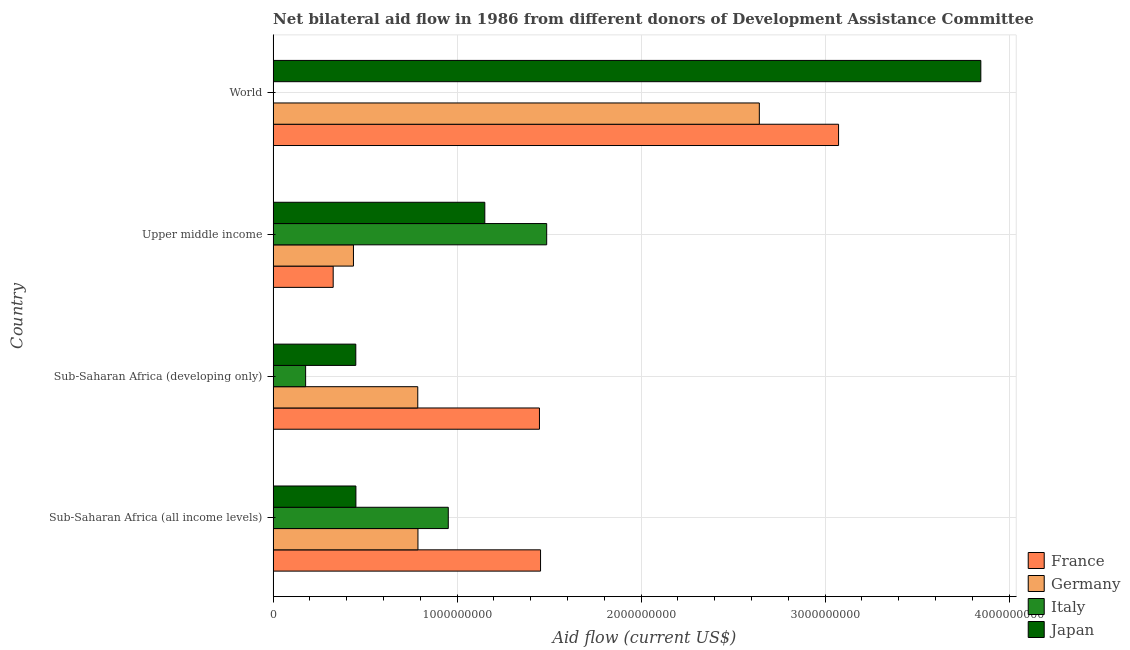How many different coloured bars are there?
Your answer should be compact. 4. Are the number of bars per tick equal to the number of legend labels?
Your response must be concise. Yes. How many bars are there on the 1st tick from the top?
Make the answer very short. 4. How many bars are there on the 3rd tick from the bottom?
Offer a very short reply. 4. What is the label of the 1st group of bars from the top?
Ensure brevity in your answer.  World. What is the amount of aid given by germany in Upper middle income?
Provide a succinct answer. 4.37e+08. Across all countries, what is the maximum amount of aid given by france?
Your answer should be compact. 3.07e+09. Across all countries, what is the minimum amount of aid given by germany?
Your response must be concise. 4.37e+08. In which country was the amount of aid given by italy maximum?
Your answer should be very brief. Upper middle income. In which country was the amount of aid given by italy minimum?
Your response must be concise. World. What is the total amount of aid given by japan in the graph?
Give a very brief answer. 5.90e+09. What is the difference between the amount of aid given by italy in Sub-Saharan Africa (developing only) and that in World?
Make the answer very short. 1.76e+08. What is the difference between the amount of aid given by italy in Sub-Saharan Africa (all income levels) and the amount of aid given by japan in Upper middle income?
Give a very brief answer. -1.99e+08. What is the average amount of aid given by italy per country?
Give a very brief answer. 6.54e+08. What is the difference between the amount of aid given by germany and amount of aid given by japan in Sub-Saharan Africa (developing only)?
Ensure brevity in your answer.  3.37e+08. In how many countries, is the amount of aid given by italy greater than 3600000000 US$?
Provide a short and direct response. 0. What is the ratio of the amount of aid given by japan in Upper middle income to that in World?
Offer a very short reply. 0.3. Is the difference between the amount of aid given by france in Upper middle income and World greater than the difference between the amount of aid given by italy in Upper middle income and World?
Keep it short and to the point. No. What is the difference between the highest and the second highest amount of aid given by italy?
Your answer should be compact. 5.35e+08. What is the difference between the highest and the lowest amount of aid given by japan?
Provide a short and direct response. 3.40e+09. In how many countries, is the amount of aid given by france greater than the average amount of aid given by france taken over all countries?
Your answer should be very brief. 1. Is it the case that in every country, the sum of the amount of aid given by germany and amount of aid given by italy is greater than the sum of amount of aid given by france and amount of aid given by japan?
Provide a short and direct response. No. What does the 2nd bar from the top in Sub-Saharan Africa (developing only) represents?
Give a very brief answer. Italy. What does the 4th bar from the bottom in Sub-Saharan Africa (developing only) represents?
Your answer should be very brief. Japan. How many bars are there?
Provide a succinct answer. 16. How many countries are there in the graph?
Make the answer very short. 4. Are the values on the major ticks of X-axis written in scientific E-notation?
Give a very brief answer. No. Does the graph contain any zero values?
Your answer should be compact. No. Does the graph contain grids?
Make the answer very short. Yes. Where does the legend appear in the graph?
Your answer should be compact. Bottom right. How many legend labels are there?
Make the answer very short. 4. How are the legend labels stacked?
Give a very brief answer. Vertical. What is the title of the graph?
Keep it short and to the point. Net bilateral aid flow in 1986 from different donors of Development Assistance Committee. Does "Taxes on revenue" appear as one of the legend labels in the graph?
Keep it short and to the point. No. What is the label or title of the X-axis?
Provide a short and direct response. Aid flow (current US$). What is the label or title of the Y-axis?
Give a very brief answer. Country. What is the Aid flow (current US$) of France in Sub-Saharan Africa (all income levels)?
Give a very brief answer. 1.45e+09. What is the Aid flow (current US$) of Germany in Sub-Saharan Africa (all income levels)?
Offer a very short reply. 7.87e+08. What is the Aid flow (current US$) in Italy in Sub-Saharan Africa (all income levels)?
Provide a succinct answer. 9.52e+08. What is the Aid flow (current US$) in Japan in Sub-Saharan Africa (all income levels)?
Give a very brief answer. 4.50e+08. What is the Aid flow (current US$) in France in Sub-Saharan Africa (developing only)?
Provide a short and direct response. 1.45e+09. What is the Aid flow (current US$) in Germany in Sub-Saharan Africa (developing only)?
Keep it short and to the point. 7.86e+08. What is the Aid flow (current US$) of Italy in Sub-Saharan Africa (developing only)?
Offer a very short reply. 1.77e+08. What is the Aid flow (current US$) of Japan in Sub-Saharan Africa (developing only)?
Provide a succinct answer. 4.49e+08. What is the Aid flow (current US$) of France in Upper middle income?
Offer a terse response. 3.26e+08. What is the Aid flow (current US$) of Germany in Upper middle income?
Your answer should be very brief. 4.37e+08. What is the Aid flow (current US$) of Italy in Upper middle income?
Give a very brief answer. 1.49e+09. What is the Aid flow (current US$) of Japan in Upper middle income?
Make the answer very short. 1.15e+09. What is the Aid flow (current US$) of France in World?
Give a very brief answer. 3.07e+09. What is the Aid flow (current US$) in Germany in World?
Provide a succinct answer. 2.64e+09. What is the Aid flow (current US$) in Italy in World?
Make the answer very short. 6.90e+05. What is the Aid flow (current US$) of Japan in World?
Offer a very short reply. 3.85e+09. Across all countries, what is the maximum Aid flow (current US$) of France?
Provide a succinct answer. 3.07e+09. Across all countries, what is the maximum Aid flow (current US$) in Germany?
Your answer should be very brief. 2.64e+09. Across all countries, what is the maximum Aid flow (current US$) of Italy?
Keep it short and to the point. 1.49e+09. Across all countries, what is the maximum Aid flow (current US$) of Japan?
Ensure brevity in your answer.  3.85e+09. Across all countries, what is the minimum Aid flow (current US$) in France?
Offer a very short reply. 3.26e+08. Across all countries, what is the minimum Aid flow (current US$) in Germany?
Provide a succinct answer. 4.37e+08. Across all countries, what is the minimum Aid flow (current US$) in Italy?
Ensure brevity in your answer.  6.90e+05. Across all countries, what is the minimum Aid flow (current US$) in Japan?
Offer a terse response. 4.49e+08. What is the total Aid flow (current US$) in France in the graph?
Your answer should be compact. 6.30e+09. What is the total Aid flow (current US$) of Germany in the graph?
Ensure brevity in your answer.  4.65e+09. What is the total Aid flow (current US$) in Italy in the graph?
Your answer should be compact. 2.62e+09. What is the total Aid flow (current US$) of Japan in the graph?
Your answer should be compact. 5.90e+09. What is the difference between the Aid flow (current US$) of France in Sub-Saharan Africa (all income levels) and that in Sub-Saharan Africa (developing only)?
Keep it short and to the point. 5.92e+06. What is the difference between the Aid flow (current US$) of Germany in Sub-Saharan Africa (all income levels) and that in Sub-Saharan Africa (developing only)?
Your answer should be compact. 1.05e+06. What is the difference between the Aid flow (current US$) of Italy in Sub-Saharan Africa (all income levels) and that in Sub-Saharan Africa (developing only)?
Your answer should be very brief. 7.75e+08. What is the difference between the Aid flow (current US$) in Japan in Sub-Saharan Africa (all income levels) and that in Sub-Saharan Africa (developing only)?
Keep it short and to the point. 5.90e+05. What is the difference between the Aid flow (current US$) of France in Sub-Saharan Africa (all income levels) and that in Upper middle income?
Give a very brief answer. 1.13e+09. What is the difference between the Aid flow (current US$) of Germany in Sub-Saharan Africa (all income levels) and that in Upper middle income?
Ensure brevity in your answer.  3.51e+08. What is the difference between the Aid flow (current US$) in Italy in Sub-Saharan Africa (all income levels) and that in Upper middle income?
Make the answer very short. -5.35e+08. What is the difference between the Aid flow (current US$) in Japan in Sub-Saharan Africa (all income levels) and that in Upper middle income?
Provide a short and direct response. -7.01e+08. What is the difference between the Aid flow (current US$) of France in Sub-Saharan Africa (all income levels) and that in World?
Provide a succinct answer. -1.62e+09. What is the difference between the Aid flow (current US$) of Germany in Sub-Saharan Africa (all income levels) and that in World?
Provide a short and direct response. -1.86e+09. What is the difference between the Aid flow (current US$) of Italy in Sub-Saharan Africa (all income levels) and that in World?
Give a very brief answer. 9.51e+08. What is the difference between the Aid flow (current US$) of Japan in Sub-Saharan Africa (all income levels) and that in World?
Your answer should be compact. -3.40e+09. What is the difference between the Aid flow (current US$) of France in Sub-Saharan Africa (developing only) and that in Upper middle income?
Your response must be concise. 1.12e+09. What is the difference between the Aid flow (current US$) of Germany in Sub-Saharan Africa (developing only) and that in Upper middle income?
Provide a succinct answer. 3.50e+08. What is the difference between the Aid flow (current US$) of Italy in Sub-Saharan Africa (developing only) and that in Upper middle income?
Give a very brief answer. -1.31e+09. What is the difference between the Aid flow (current US$) in Japan in Sub-Saharan Africa (developing only) and that in Upper middle income?
Provide a short and direct response. -7.01e+08. What is the difference between the Aid flow (current US$) of France in Sub-Saharan Africa (developing only) and that in World?
Make the answer very short. -1.63e+09. What is the difference between the Aid flow (current US$) in Germany in Sub-Saharan Africa (developing only) and that in World?
Give a very brief answer. -1.86e+09. What is the difference between the Aid flow (current US$) of Italy in Sub-Saharan Africa (developing only) and that in World?
Provide a short and direct response. 1.76e+08. What is the difference between the Aid flow (current US$) of Japan in Sub-Saharan Africa (developing only) and that in World?
Provide a short and direct response. -3.40e+09. What is the difference between the Aid flow (current US$) in France in Upper middle income and that in World?
Make the answer very short. -2.75e+09. What is the difference between the Aid flow (current US$) in Germany in Upper middle income and that in World?
Make the answer very short. -2.21e+09. What is the difference between the Aid flow (current US$) in Italy in Upper middle income and that in World?
Provide a succinct answer. 1.49e+09. What is the difference between the Aid flow (current US$) of Japan in Upper middle income and that in World?
Make the answer very short. -2.70e+09. What is the difference between the Aid flow (current US$) of France in Sub-Saharan Africa (all income levels) and the Aid flow (current US$) of Germany in Sub-Saharan Africa (developing only)?
Make the answer very short. 6.67e+08. What is the difference between the Aid flow (current US$) in France in Sub-Saharan Africa (all income levels) and the Aid flow (current US$) in Italy in Sub-Saharan Africa (developing only)?
Provide a short and direct response. 1.28e+09. What is the difference between the Aid flow (current US$) of France in Sub-Saharan Africa (all income levels) and the Aid flow (current US$) of Japan in Sub-Saharan Africa (developing only)?
Provide a short and direct response. 1.00e+09. What is the difference between the Aid flow (current US$) of Germany in Sub-Saharan Africa (all income levels) and the Aid flow (current US$) of Italy in Sub-Saharan Africa (developing only)?
Your answer should be very brief. 6.11e+08. What is the difference between the Aid flow (current US$) in Germany in Sub-Saharan Africa (all income levels) and the Aid flow (current US$) in Japan in Sub-Saharan Africa (developing only)?
Provide a short and direct response. 3.38e+08. What is the difference between the Aid flow (current US$) in Italy in Sub-Saharan Africa (all income levels) and the Aid flow (current US$) in Japan in Sub-Saharan Africa (developing only)?
Offer a terse response. 5.03e+08. What is the difference between the Aid flow (current US$) of France in Sub-Saharan Africa (all income levels) and the Aid flow (current US$) of Germany in Upper middle income?
Your answer should be very brief. 1.02e+09. What is the difference between the Aid flow (current US$) in France in Sub-Saharan Africa (all income levels) and the Aid flow (current US$) in Italy in Upper middle income?
Your answer should be compact. -3.34e+07. What is the difference between the Aid flow (current US$) of France in Sub-Saharan Africa (all income levels) and the Aid flow (current US$) of Japan in Upper middle income?
Give a very brief answer. 3.03e+08. What is the difference between the Aid flow (current US$) in Germany in Sub-Saharan Africa (all income levels) and the Aid flow (current US$) in Italy in Upper middle income?
Offer a very short reply. -7.00e+08. What is the difference between the Aid flow (current US$) in Germany in Sub-Saharan Africa (all income levels) and the Aid flow (current US$) in Japan in Upper middle income?
Give a very brief answer. -3.63e+08. What is the difference between the Aid flow (current US$) of Italy in Sub-Saharan Africa (all income levels) and the Aid flow (current US$) of Japan in Upper middle income?
Provide a succinct answer. -1.99e+08. What is the difference between the Aid flow (current US$) in France in Sub-Saharan Africa (all income levels) and the Aid flow (current US$) in Germany in World?
Offer a terse response. -1.19e+09. What is the difference between the Aid flow (current US$) in France in Sub-Saharan Africa (all income levels) and the Aid flow (current US$) in Italy in World?
Give a very brief answer. 1.45e+09. What is the difference between the Aid flow (current US$) of France in Sub-Saharan Africa (all income levels) and the Aid flow (current US$) of Japan in World?
Ensure brevity in your answer.  -2.39e+09. What is the difference between the Aid flow (current US$) of Germany in Sub-Saharan Africa (all income levels) and the Aid flow (current US$) of Italy in World?
Offer a very short reply. 7.86e+08. What is the difference between the Aid flow (current US$) in Germany in Sub-Saharan Africa (all income levels) and the Aid flow (current US$) in Japan in World?
Make the answer very short. -3.06e+09. What is the difference between the Aid flow (current US$) of Italy in Sub-Saharan Africa (all income levels) and the Aid flow (current US$) of Japan in World?
Keep it short and to the point. -2.89e+09. What is the difference between the Aid flow (current US$) in France in Sub-Saharan Africa (developing only) and the Aid flow (current US$) in Germany in Upper middle income?
Provide a short and direct response. 1.01e+09. What is the difference between the Aid flow (current US$) in France in Sub-Saharan Africa (developing only) and the Aid flow (current US$) in Italy in Upper middle income?
Ensure brevity in your answer.  -3.93e+07. What is the difference between the Aid flow (current US$) in France in Sub-Saharan Africa (developing only) and the Aid flow (current US$) in Japan in Upper middle income?
Offer a very short reply. 2.97e+08. What is the difference between the Aid flow (current US$) of Germany in Sub-Saharan Africa (developing only) and the Aid flow (current US$) of Italy in Upper middle income?
Provide a short and direct response. -7.01e+08. What is the difference between the Aid flow (current US$) of Germany in Sub-Saharan Africa (developing only) and the Aid flow (current US$) of Japan in Upper middle income?
Give a very brief answer. -3.64e+08. What is the difference between the Aid flow (current US$) in Italy in Sub-Saharan Africa (developing only) and the Aid flow (current US$) in Japan in Upper middle income?
Offer a terse response. -9.74e+08. What is the difference between the Aid flow (current US$) of France in Sub-Saharan Africa (developing only) and the Aid flow (current US$) of Germany in World?
Offer a very short reply. -1.19e+09. What is the difference between the Aid flow (current US$) in France in Sub-Saharan Africa (developing only) and the Aid flow (current US$) in Italy in World?
Your answer should be very brief. 1.45e+09. What is the difference between the Aid flow (current US$) of France in Sub-Saharan Africa (developing only) and the Aid flow (current US$) of Japan in World?
Provide a succinct answer. -2.40e+09. What is the difference between the Aid flow (current US$) in Germany in Sub-Saharan Africa (developing only) and the Aid flow (current US$) in Italy in World?
Your answer should be very brief. 7.85e+08. What is the difference between the Aid flow (current US$) in Germany in Sub-Saharan Africa (developing only) and the Aid flow (current US$) in Japan in World?
Offer a terse response. -3.06e+09. What is the difference between the Aid flow (current US$) in Italy in Sub-Saharan Africa (developing only) and the Aid flow (current US$) in Japan in World?
Offer a terse response. -3.67e+09. What is the difference between the Aid flow (current US$) of France in Upper middle income and the Aid flow (current US$) of Germany in World?
Provide a short and direct response. -2.32e+09. What is the difference between the Aid flow (current US$) in France in Upper middle income and the Aid flow (current US$) in Italy in World?
Give a very brief answer. 3.26e+08. What is the difference between the Aid flow (current US$) in France in Upper middle income and the Aid flow (current US$) in Japan in World?
Ensure brevity in your answer.  -3.52e+09. What is the difference between the Aid flow (current US$) in Germany in Upper middle income and the Aid flow (current US$) in Italy in World?
Give a very brief answer. 4.36e+08. What is the difference between the Aid flow (current US$) of Germany in Upper middle income and the Aid flow (current US$) of Japan in World?
Offer a terse response. -3.41e+09. What is the difference between the Aid flow (current US$) of Italy in Upper middle income and the Aid flow (current US$) of Japan in World?
Keep it short and to the point. -2.36e+09. What is the average Aid flow (current US$) of France per country?
Keep it short and to the point. 1.58e+09. What is the average Aid flow (current US$) of Germany per country?
Make the answer very short. 1.16e+09. What is the average Aid flow (current US$) in Italy per country?
Keep it short and to the point. 6.54e+08. What is the average Aid flow (current US$) of Japan per country?
Make the answer very short. 1.47e+09. What is the difference between the Aid flow (current US$) in France and Aid flow (current US$) in Germany in Sub-Saharan Africa (all income levels)?
Provide a short and direct response. 6.66e+08. What is the difference between the Aid flow (current US$) in France and Aid flow (current US$) in Italy in Sub-Saharan Africa (all income levels)?
Make the answer very short. 5.01e+08. What is the difference between the Aid flow (current US$) of France and Aid flow (current US$) of Japan in Sub-Saharan Africa (all income levels)?
Make the answer very short. 1.00e+09. What is the difference between the Aid flow (current US$) of Germany and Aid flow (current US$) of Italy in Sub-Saharan Africa (all income levels)?
Ensure brevity in your answer.  -1.65e+08. What is the difference between the Aid flow (current US$) of Germany and Aid flow (current US$) of Japan in Sub-Saharan Africa (all income levels)?
Provide a succinct answer. 3.37e+08. What is the difference between the Aid flow (current US$) of Italy and Aid flow (current US$) of Japan in Sub-Saharan Africa (all income levels)?
Make the answer very short. 5.02e+08. What is the difference between the Aid flow (current US$) of France and Aid flow (current US$) of Germany in Sub-Saharan Africa (developing only)?
Offer a terse response. 6.61e+08. What is the difference between the Aid flow (current US$) in France and Aid flow (current US$) in Italy in Sub-Saharan Africa (developing only)?
Your response must be concise. 1.27e+09. What is the difference between the Aid flow (current US$) in France and Aid flow (current US$) in Japan in Sub-Saharan Africa (developing only)?
Keep it short and to the point. 9.98e+08. What is the difference between the Aid flow (current US$) in Germany and Aid flow (current US$) in Italy in Sub-Saharan Africa (developing only)?
Your answer should be very brief. 6.10e+08. What is the difference between the Aid flow (current US$) in Germany and Aid flow (current US$) in Japan in Sub-Saharan Africa (developing only)?
Your answer should be very brief. 3.37e+08. What is the difference between the Aid flow (current US$) of Italy and Aid flow (current US$) of Japan in Sub-Saharan Africa (developing only)?
Provide a short and direct response. -2.73e+08. What is the difference between the Aid flow (current US$) of France and Aid flow (current US$) of Germany in Upper middle income?
Offer a terse response. -1.10e+08. What is the difference between the Aid flow (current US$) of France and Aid flow (current US$) of Italy in Upper middle income?
Your answer should be very brief. -1.16e+09. What is the difference between the Aid flow (current US$) in France and Aid flow (current US$) in Japan in Upper middle income?
Make the answer very short. -8.24e+08. What is the difference between the Aid flow (current US$) in Germany and Aid flow (current US$) in Italy in Upper middle income?
Offer a very short reply. -1.05e+09. What is the difference between the Aid flow (current US$) of Germany and Aid flow (current US$) of Japan in Upper middle income?
Offer a terse response. -7.14e+08. What is the difference between the Aid flow (current US$) of Italy and Aid flow (current US$) of Japan in Upper middle income?
Offer a very short reply. 3.36e+08. What is the difference between the Aid flow (current US$) of France and Aid flow (current US$) of Germany in World?
Provide a short and direct response. 4.31e+08. What is the difference between the Aid flow (current US$) in France and Aid flow (current US$) in Italy in World?
Offer a very short reply. 3.07e+09. What is the difference between the Aid flow (current US$) of France and Aid flow (current US$) of Japan in World?
Your answer should be compact. -7.73e+08. What is the difference between the Aid flow (current US$) of Germany and Aid flow (current US$) of Italy in World?
Make the answer very short. 2.64e+09. What is the difference between the Aid flow (current US$) in Germany and Aid flow (current US$) in Japan in World?
Your response must be concise. -1.20e+09. What is the difference between the Aid flow (current US$) of Italy and Aid flow (current US$) of Japan in World?
Your response must be concise. -3.85e+09. What is the ratio of the Aid flow (current US$) of Germany in Sub-Saharan Africa (all income levels) to that in Sub-Saharan Africa (developing only)?
Make the answer very short. 1. What is the ratio of the Aid flow (current US$) in Italy in Sub-Saharan Africa (all income levels) to that in Sub-Saharan Africa (developing only)?
Give a very brief answer. 5.39. What is the ratio of the Aid flow (current US$) of Japan in Sub-Saharan Africa (all income levels) to that in Sub-Saharan Africa (developing only)?
Your answer should be compact. 1. What is the ratio of the Aid flow (current US$) in France in Sub-Saharan Africa (all income levels) to that in Upper middle income?
Offer a terse response. 4.45. What is the ratio of the Aid flow (current US$) in Germany in Sub-Saharan Africa (all income levels) to that in Upper middle income?
Provide a succinct answer. 1.8. What is the ratio of the Aid flow (current US$) in Italy in Sub-Saharan Africa (all income levels) to that in Upper middle income?
Provide a succinct answer. 0.64. What is the ratio of the Aid flow (current US$) in Japan in Sub-Saharan Africa (all income levels) to that in Upper middle income?
Offer a terse response. 0.39. What is the ratio of the Aid flow (current US$) in France in Sub-Saharan Africa (all income levels) to that in World?
Offer a terse response. 0.47. What is the ratio of the Aid flow (current US$) of Germany in Sub-Saharan Africa (all income levels) to that in World?
Provide a short and direct response. 0.3. What is the ratio of the Aid flow (current US$) in Italy in Sub-Saharan Africa (all income levels) to that in World?
Your response must be concise. 1379.68. What is the ratio of the Aid flow (current US$) of Japan in Sub-Saharan Africa (all income levels) to that in World?
Offer a very short reply. 0.12. What is the ratio of the Aid flow (current US$) of France in Sub-Saharan Africa (developing only) to that in Upper middle income?
Your response must be concise. 4.43. What is the ratio of the Aid flow (current US$) of Germany in Sub-Saharan Africa (developing only) to that in Upper middle income?
Offer a very short reply. 1.8. What is the ratio of the Aid flow (current US$) of Italy in Sub-Saharan Africa (developing only) to that in Upper middle income?
Keep it short and to the point. 0.12. What is the ratio of the Aid flow (current US$) in Japan in Sub-Saharan Africa (developing only) to that in Upper middle income?
Make the answer very short. 0.39. What is the ratio of the Aid flow (current US$) of France in Sub-Saharan Africa (developing only) to that in World?
Offer a terse response. 0.47. What is the ratio of the Aid flow (current US$) of Germany in Sub-Saharan Africa (developing only) to that in World?
Give a very brief answer. 0.3. What is the ratio of the Aid flow (current US$) of Italy in Sub-Saharan Africa (developing only) to that in World?
Offer a very short reply. 255.99. What is the ratio of the Aid flow (current US$) of Japan in Sub-Saharan Africa (developing only) to that in World?
Make the answer very short. 0.12. What is the ratio of the Aid flow (current US$) of France in Upper middle income to that in World?
Provide a short and direct response. 0.11. What is the ratio of the Aid flow (current US$) of Germany in Upper middle income to that in World?
Give a very brief answer. 0.17. What is the ratio of the Aid flow (current US$) in Italy in Upper middle income to that in World?
Ensure brevity in your answer.  2154.74. What is the ratio of the Aid flow (current US$) of Japan in Upper middle income to that in World?
Give a very brief answer. 0.3. What is the difference between the highest and the second highest Aid flow (current US$) of France?
Your answer should be compact. 1.62e+09. What is the difference between the highest and the second highest Aid flow (current US$) of Germany?
Ensure brevity in your answer.  1.86e+09. What is the difference between the highest and the second highest Aid flow (current US$) in Italy?
Offer a very short reply. 5.35e+08. What is the difference between the highest and the second highest Aid flow (current US$) in Japan?
Your answer should be compact. 2.70e+09. What is the difference between the highest and the lowest Aid flow (current US$) of France?
Provide a short and direct response. 2.75e+09. What is the difference between the highest and the lowest Aid flow (current US$) in Germany?
Your response must be concise. 2.21e+09. What is the difference between the highest and the lowest Aid flow (current US$) in Italy?
Your response must be concise. 1.49e+09. What is the difference between the highest and the lowest Aid flow (current US$) in Japan?
Offer a very short reply. 3.40e+09. 